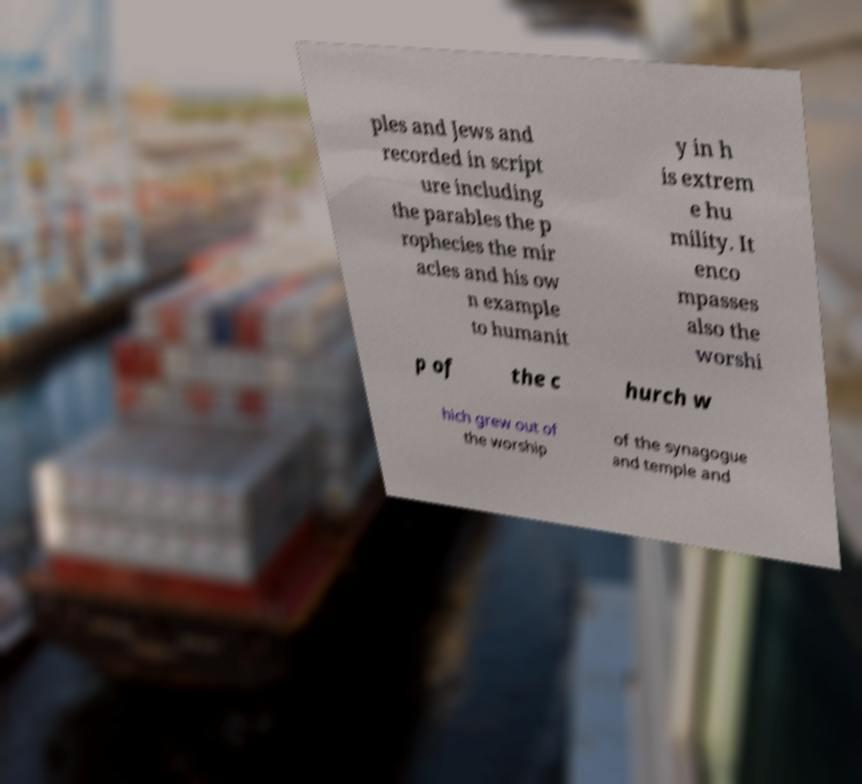There's text embedded in this image that I need extracted. Can you transcribe it verbatim? ples and Jews and recorded in script ure including the parables the p rophecies the mir acles and his ow n example to humanit y in h is extrem e hu mility. It enco mpasses also the worshi p of the c hurch w hich grew out of the worship of the synagogue and temple and 